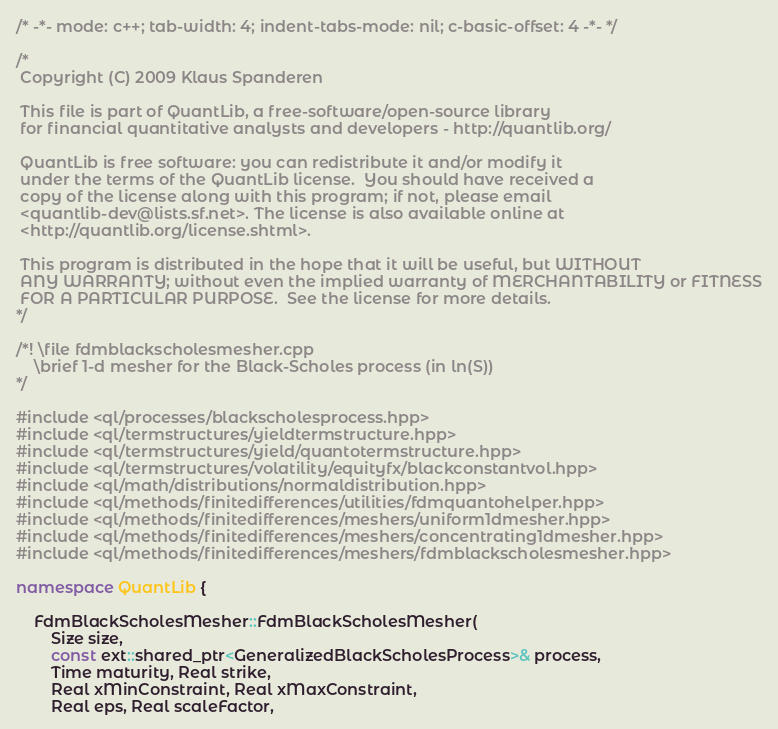Convert code to text. <code><loc_0><loc_0><loc_500><loc_500><_C++_>/* -*- mode: c++; tab-width: 4; indent-tabs-mode: nil; c-basic-offset: 4 -*- */

/*
 Copyright (C) 2009 Klaus Spanderen

 This file is part of QuantLib, a free-software/open-source library
 for financial quantitative analysts and developers - http://quantlib.org/

 QuantLib is free software: you can redistribute it and/or modify it
 under the terms of the QuantLib license.  You should have received a
 copy of the license along with this program; if not, please email
 <quantlib-dev@lists.sf.net>. The license is also available online at
 <http://quantlib.org/license.shtml>.

 This program is distributed in the hope that it will be useful, but WITHOUT
 ANY WARRANTY; without even the implied warranty of MERCHANTABILITY or FITNESS
 FOR A PARTICULAR PURPOSE.  See the license for more details.
*/

/*! \file fdmblackscholesmesher.cpp
    \brief 1-d mesher for the Black-Scholes process (in ln(S))
*/

#include <ql/processes/blackscholesprocess.hpp>
#include <ql/termstructures/yieldtermstructure.hpp>
#include <ql/termstructures/yield/quantotermstructure.hpp>
#include <ql/termstructures/volatility/equityfx/blackconstantvol.hpp>
#include <ql/math/distributions/normaldistribution.hpp>
#include <ql/methods/finitedifferences/utilities/fdmquantohelper.hpp>
#include <ql/methods/finitedifferences/meshers/uniform1dmesher.hpp>
#include <ql/methods/finitedifferences/meshers/concentrating1dmesher.hpp>
#include <ql/methods/finitedifferences/meshers/fdmblackscholesmesher.hpp>

namespace QuantLib {

    FdmBlackScholesMesher::FdmBlackScholesMesher(
        Size size,
        const ext::shared_ptr<GeneralizedBlackScholesProcess>& process,
        Time maturity, Real strike,
        Real xMinConstraint, Real xMaxConstraint,
        Real eps, Real scaleFactor,</code> 